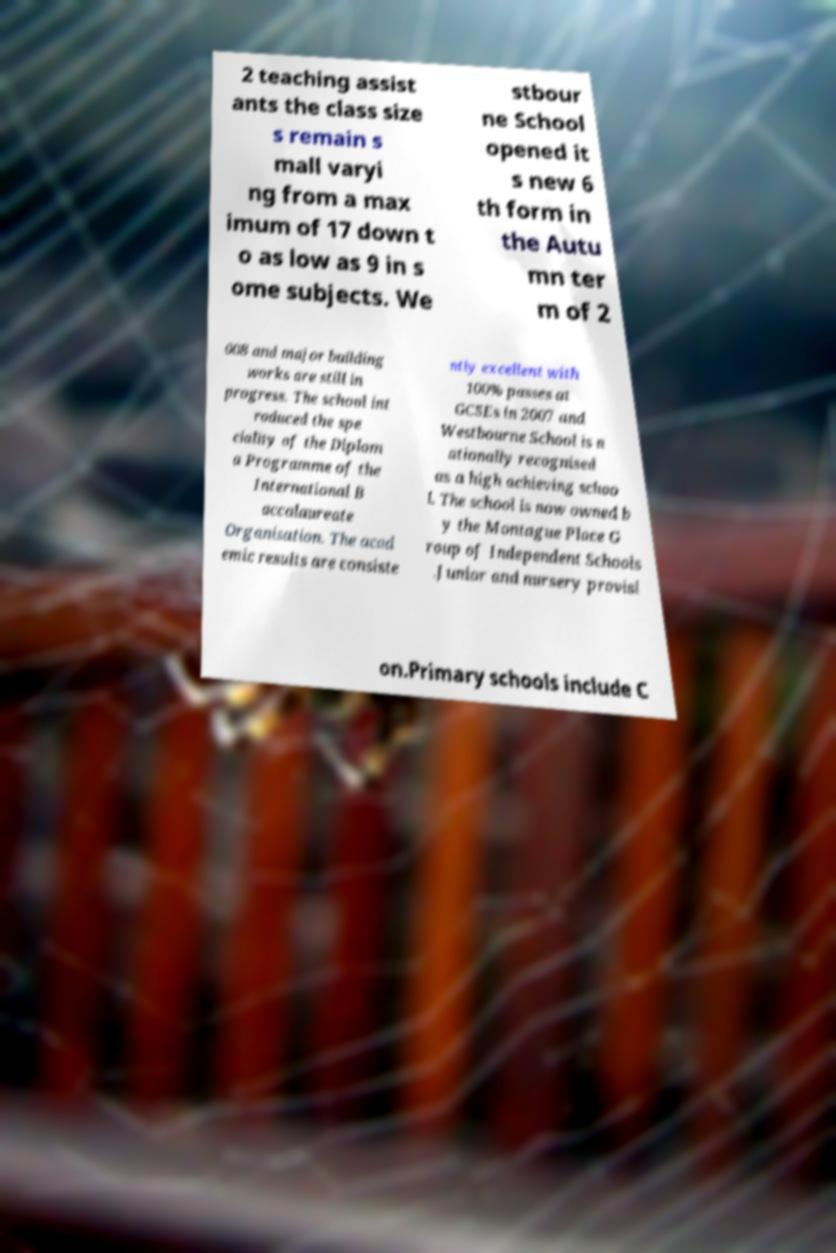For documentation purposes, I need the text within this image transcribed. Could you provide that? 2 teaching assist ants the class size s remain s mall varyi ng from a max imum of 17 down t o as low as 9 in s ome subjects. We stbour ne School opened it s new 6 th form in the Autu mn ter m of 2 008 and major building works are still in progress. The school int roduced the spe ciality of the Diplom a Programme of the International B accalaureate Organisation. The acad emic results are consiste ntly excellent with 100% passes at GCSEs in 2007 and Westbourne School is n ationally recognised as a high achieving schoo l. The school is now owned b y the Montague Place G roup of Independent Schools .Junior and nursery provisi on.Primary schools include C 